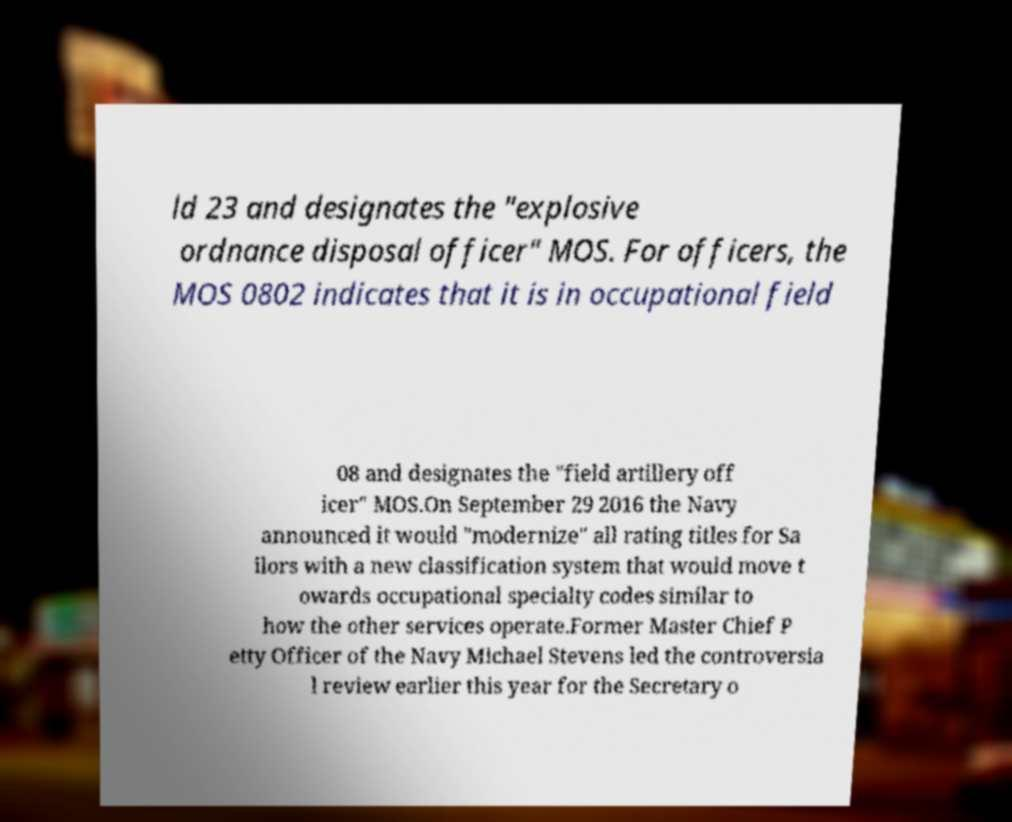What messages or text are displayed in this image? I need them in a readable, typed format. ld 23 and designates the "explosive ordnance disposal officer" MOS. For officers, the MOS 0802 indicates that it is in occupational field 08 and designates the "field artillery off icer" MOS.On September 29 2016 the Navy announced it would "modernize" all rating titles for Sa ilors with a new classification system that would move t owards occupational specialty codes similar to how the other services operate.Former Master Chief P etty Officer of the Navy Michael Stevens led the controversia l review earlier this year for the Secretary o 